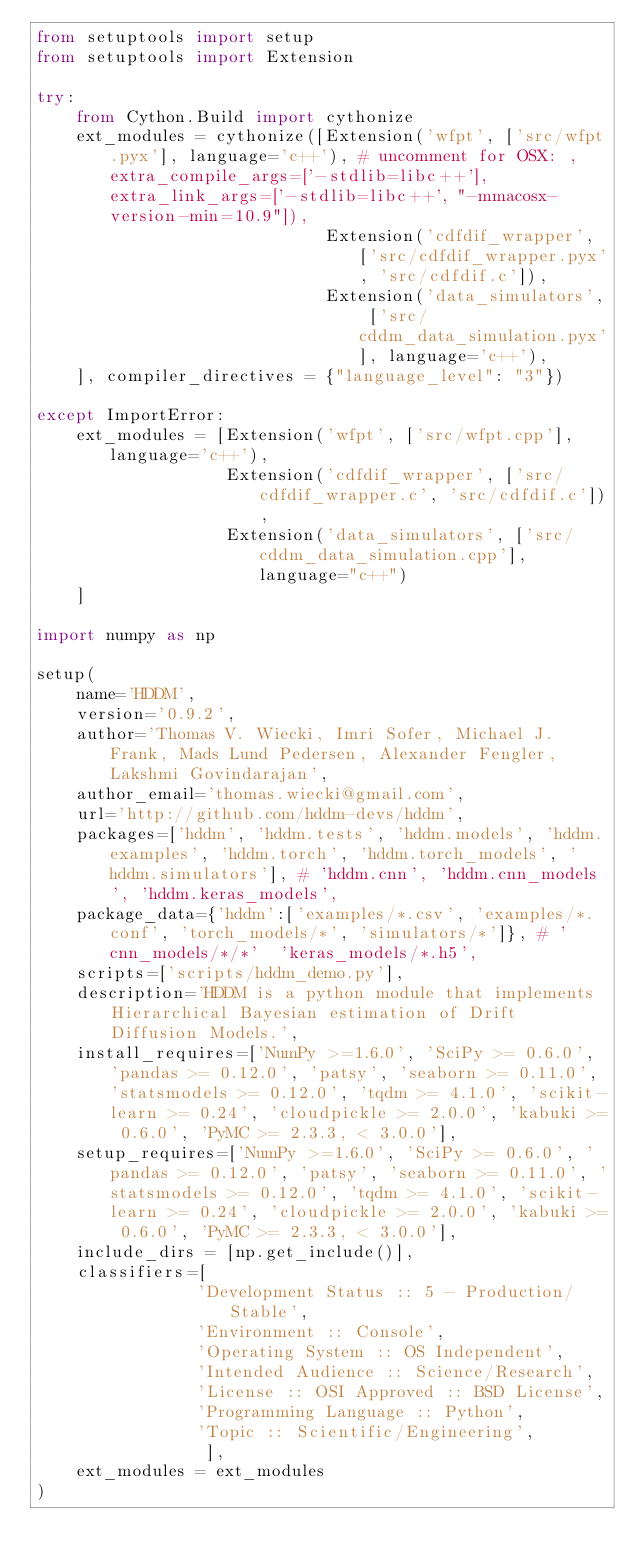Convert code to text. <code><loc_0><loc_0><loc_500><loc_500><_Python_>from setuptools import setup
from setuptools import Extension

try:
    from Cython.Build import cythonize
    ext_modules = cythonize([Extension('wfpt', ['src/wfpt.pyx'], language='c++'), # uncomment for OSX: , extra_compile_args=['-stdlib=libc++'], extra_link_args=['-stdlib=libc++', "-mmacosx-version-min=10.9"]),
                             Extension('cdfdif_wrapper', ['src/cdfdif_wrapper.pyx', 'src/cdfdif.c']),
                             Extension('data_simulators', ['src/cddm_data_simulation.pyx'], language='c++'),
    ], compiler_directives = {"language_level": "3"})

except ImportError:
    ext_modules = [Extension('wfpt', ['src/wfpt.cpp'], language='c++'),
                   Extension('cdfdif_wrapper', ['src/cdfdif_wrapper.c', 'src/cdfdif.c']),
                   Extension('data_simulators', ['src/cddm_data_simulation.cpp'], language="c++")
    ]

import numpy as np

setup(
    name='HDDM',
    version='0.9.2',
    author='Thomas V. Wiecki, Imri Sofer, Michael J. Frank, Mads Lund Pedersen, Alexander Fengler, Lakshmi Govindarajan',
    author_email='thomas.wiecki@gmail.com',
    url='http://github.com/hddm-devs/hddm',
    packages=['hddm', 'hddm.tests', 'hddm.models', 'hddm.examples', 'hddm.torch', 'hddm.torch_models', 'hddm.simulators'], # 'hddm.cnn', 'hddm.cnn_models', 'hddm.keras_models',
    package_data={'hddm':['examples/*.csv', 'examples/*.conf', 'torch_models/*', 'simulators/*']}, # 'cnn_models/*/*'  'keras_models/*.h5',
    scripts=['scripts/hddm_demo.py'],
    description='HDDM is a python module that implements Hierarchical Bayesian estimation of Drift Diffusion Models.',
    install_requires=['NumPy >=1.6.0', 'SciPy >= 0.6.0', 'pandas >= 0.12.0', 'patsy', 'seaborn >= 0.11.0', 'statsmodels >= 0.12.0', 'tqdm >= 4.1.0', 'scikit-learn >= 0.24', 'cloudpickle >= 2.0.0', 'kabuki >= 0.6.0', 'PyMC >= 2.3.3, < 3.0.0'],
    setup_requires=['NumPy >=1.6.0', 'SciPy >= 0.6.0', 'pandas >= 0.12.0', 'patsy', 'seaborn >= 0.11.0', 'statsmodels >= 0.12.0', 'tqdm >= 4.1.0', 'scikit-learn >= 0.24', 'cloudpickle >= 2.0.0', 'kabuki >= 0.6.0', 'PyMC >= 2.3.3, < 3.0.0'],
    include_dirs = [np.get_include()],
    classifiers=[
                'Development Status :: 5 - Production/Stable',
                'Environment :: Console',
                'Operating System :: OS Independent',
                'Intended Audience :: Science/Research',
                'License :: OSI Approved :: BSD License',
                'Programming Language :: Python',
                'Topic :: Scientific/Engineering',
                 ],
    ext_modules = ext_modules
)
</code> 